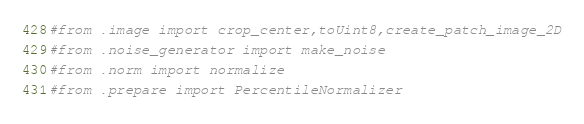<code> <loc_0><loc_0><loc_500><loc_500><_Python_>
#from .image import crop_center,toUint8,create_patch_image_2D
#from .noise_generator import make_noise
#from .norm import normalize
#from .prepare import PercentileNormalizer
</code> 